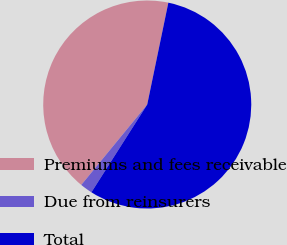<chart> <loc_0><loc_0><loc_500><loc_500><pie_chart><fcel>Premiums and fees receivable<fcel>Due from reinsurers<fcel>Total<nl><fcel>42.32%<fcel>1.92%<fcel>55.76%<nl></chart> 